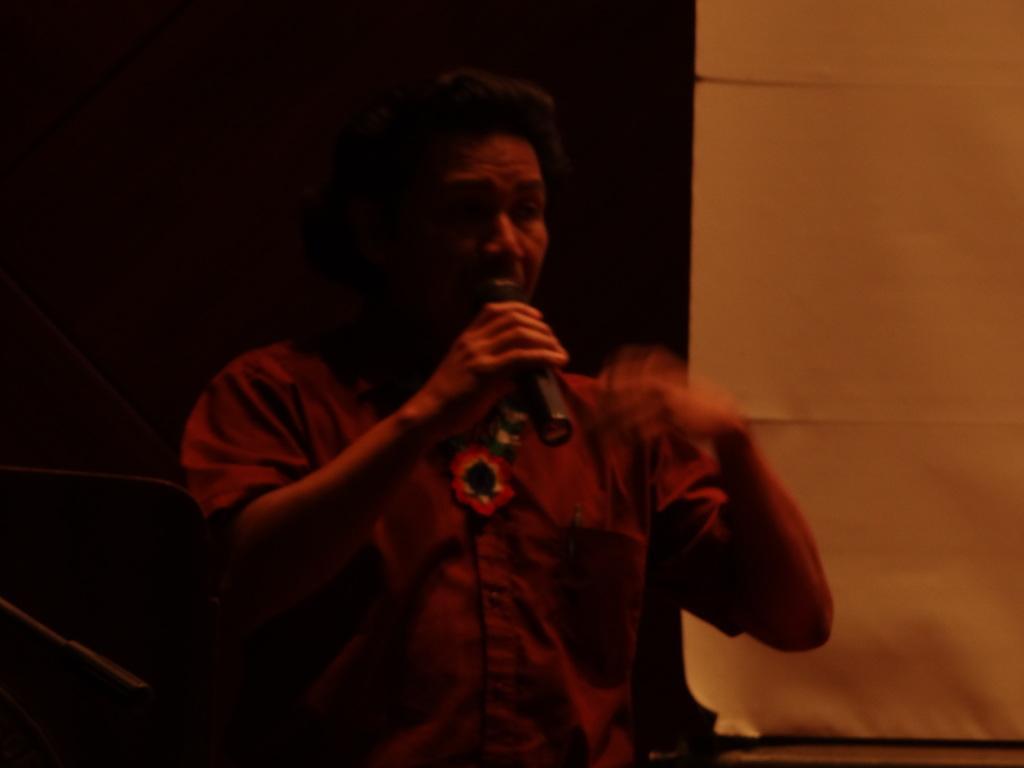Describe this image in one or two sentences. In this picture there is a person wearing violet shirt is holding a mic in his hand and speaking in front of it and there is an yellow color object in the right corner. 